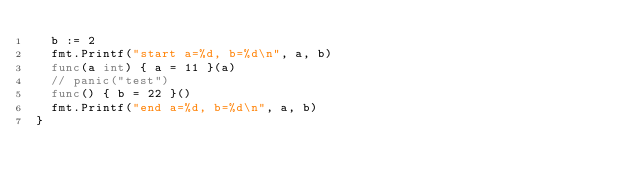<code> <loc_0><loc_0><loc_500><loc_500><_Go_>	b := 2
	fmt.Printf("start a=%d, b=%d\n", a, b)
	func(a int) { a = 11 }(a)
	// panic("test")
	func() { b = 22 }()
	fmt.Printf("end a=%d, b=%d\n", a, b)
}
</code> 